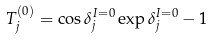Convert formula to latex. <formula><loc_0><loc_0><loc_500><loc_500>T ^ { ( 0 ) } _ { j } = \cos \delta ^ { I = 0 } _ { j } \exp \delta ^ { I = 0 } _ { j } - 1</formula> 